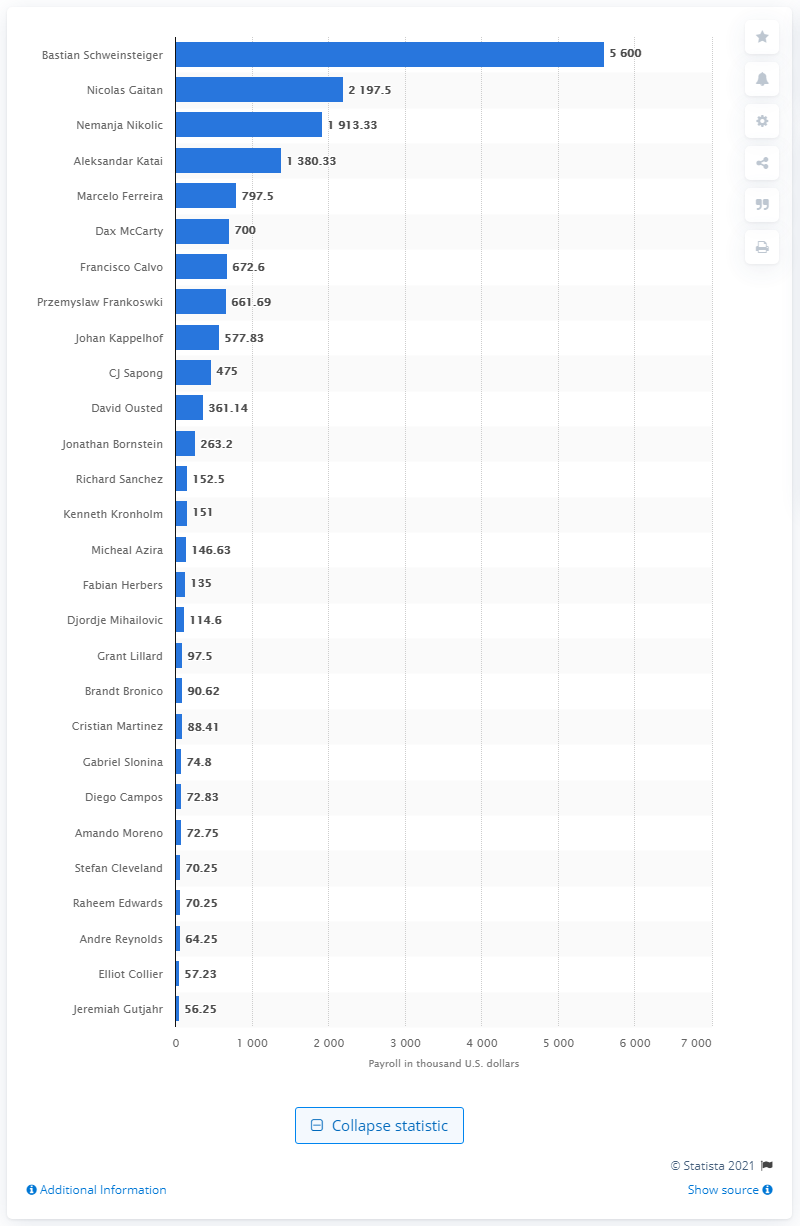Give some essential details in this illustration. In 2019, Bastian Schweinsteiger received an annual salary of 5.6 million dollars. 